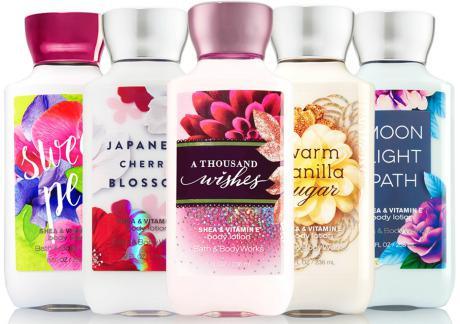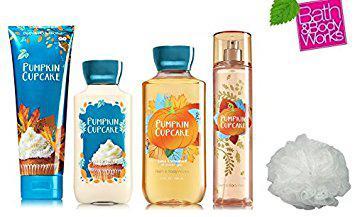The first image is the image on the left, the second image is the image on the right. Assess this claim about the two images: "An image contains at least one horizontal row of five skincare products of the same size and shape.". Correct or not? Answer yes or no. Yes. 